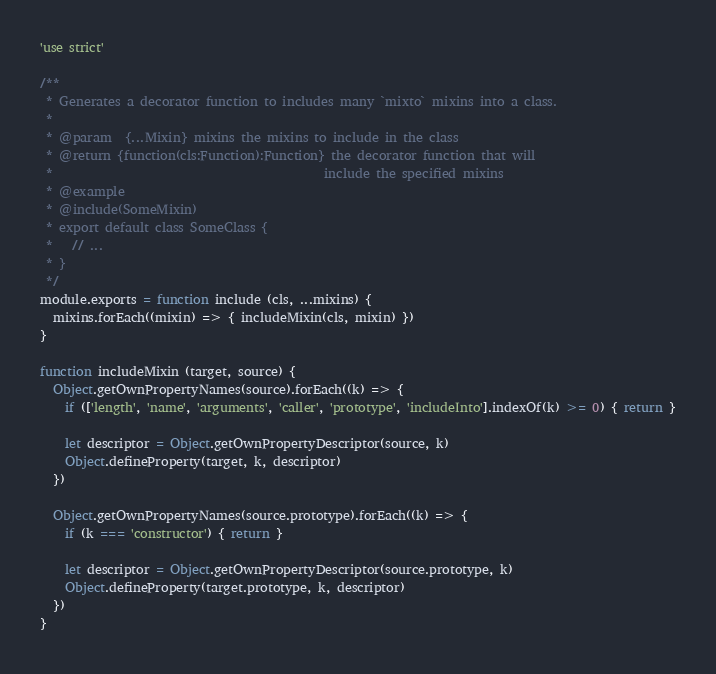<code> <loc_0><loc_0><loc_500><loc_500><_JavaScript_>'use strict'

/**
 * Generates a decorator function to includes many `mixto` mixins into a class.
 *
 * @param  {...Mixin} mixins the mixins to include in the class
 * @return {function(cls:Function):Function} the decorator function that will
 *                                           include the specified mixins
 * @example
 * @include(SomeMixin)
 * export default class SomeClass {
 *   // ...
 * }
 */
module.exports = function include (cls, ...mixins) {
  mixins.forEach((mixin) => { includeMixin(cls, mixin) })
}

function includeMixin (target, source) {
  Object.getOwnPropertyNames(source).forEach((k) => {
    if (['length', 'name', 'arguments', 'caller', 'prototype', 'includeInto'].indexOf(k) >= 0) { return }

    let descriptor = Object.getOwnPropertyDescriptor(source, k)
    Object.defineProperty(target, k, descriptor)
  })

  Object.getOwnPropertyNames(source.prototype).forEach((k) => {
    if (k === 'constructor') { return }

    let descriptor = Object.getOwnPropertyDescriptor(source.prototype, k)
    Object.defineProperty(target.prototype, k, descriptor)
  })
}
</code> 